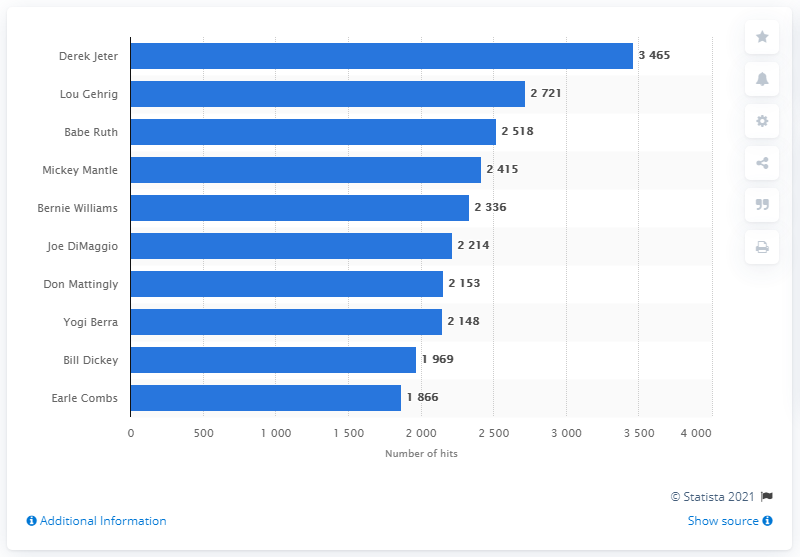Point out several critical features in this image. Derek Jeter holds the record for the most hits in the history of the New York Yankees franchise. 